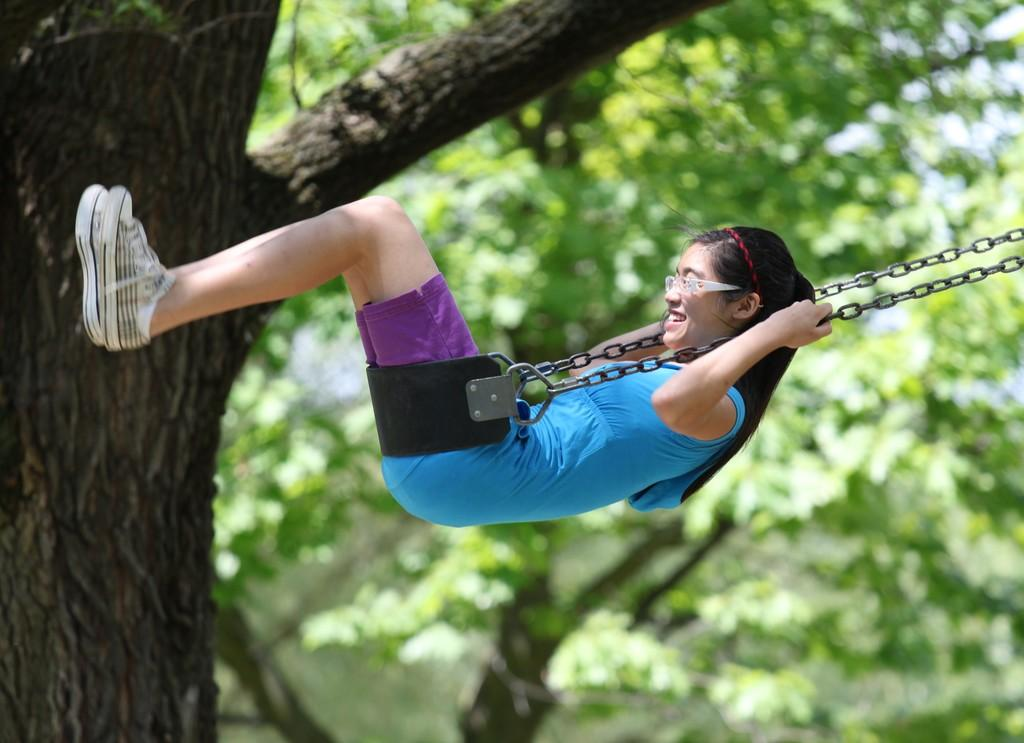Who is the main subject in the image? There is a girl in the image. What is the girl doing in the image? The girl is sitting on a swing. What can be seen on the left side of the image? There is a tree on the left side of the image. What type of trees are visible in the background of the image? There are trees with green leaves in the background of the image. What type of silk fabric is draped over the swing in the image? There is no silk fabric present in the image; the girl is sitting on a swing without any fabric draped over it. 